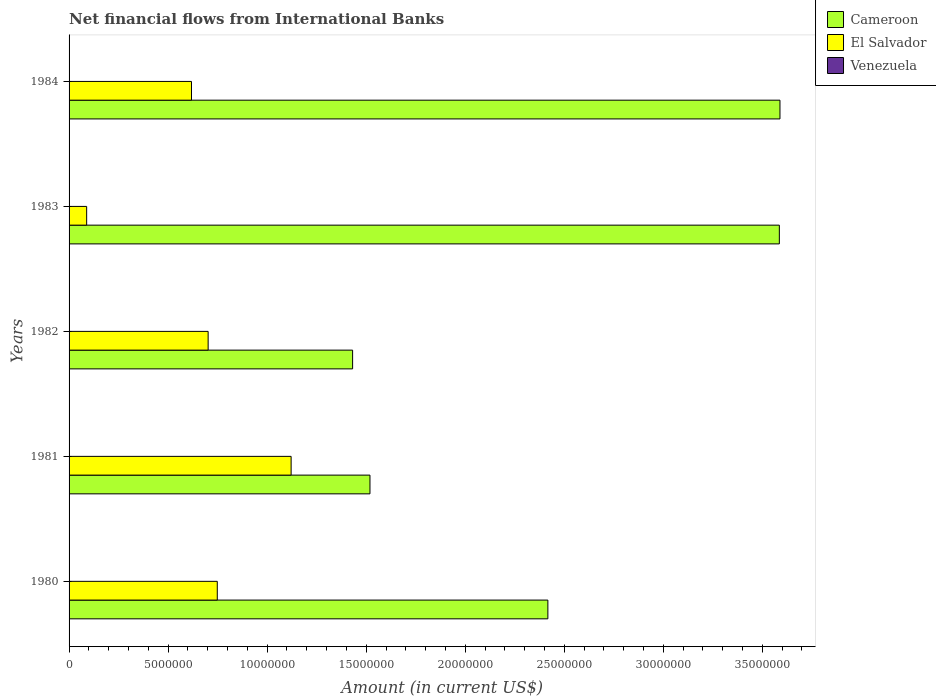How many different coloured bars are there?
Ensure brevity in your answer.  2. How many bars are there on the 3rd tick from the bottom?
Your answer should be very brief. 2. In how many cases, is the number of bars for a given year not equal to the number of legend labels?
Your answer should be very brief. 5. What is the net financial aid flows in Cameroon in 1983?
Your answer should be very brief. 3.59e+07. Across all years, what is the maximum net financial aid flows in Cameroon?
Offer a very short reply. 3.59e+07. Across all years, what is the minimum net financial aid flows in El Salvador?
Provide a short and direct response. 8.88e+05. What is the total net financial aid flows in Cameroon in the graph?
Your answer should be compact. 1.25e+08. What is the difference between the net financial aid flows in Cameroon in 1980 and that in 1981?
Provide a succinct answer. 8.98e+06. What is the difference between the net financial aid flows in El Salvador in 1981 and the net financial aid flows in Cameroon in 1980?
Offer a terse response. -1.30e+07. What is the average net financial aid flows in El Salvador per year?
Offer a terse response. 6.56e+06. In the year 1984, what is the difference between the net financial aid flows in El Salvador and net financial aid flows in Cameroon?
Keep it short and to the point. -2.97e+07. In how many years, is the net financial aid flows in Cameroon greater than 9000000 US$?
Give a very brief answer. 5. Is the net financial aid flows in El Salvador in 1980 less than that in 1982?
Your answer should be very brief. No. What is the difference between the highest and the second highest net financial aid flows in Cameroon?
Offer a very short reply. 3.10e+04. What is the difference between the highest and the lowest net financial aid flows in El Salvador?
Your answer should be very brief. 1.03e+07. In how many years, is the net financial aid flows in Venezuela greater than the average net financial aid flows in Venezuela taken over all years?
Give a very brief answer. 0. Is it the case that in every year, the sum of the net financial aid flows in El Salvador and net financial aid flows in Cameroon is greater than the net financial aid flows in Venezuela?
Provide a short and direct response. Yes. How many bars are there?
Provide a short and direct response. 10. Are the values on the major ticks of X-axis written in scientific E-notation?
Make the answer very short. No. Does the graph contain any zero values?
Your response must be concise. Yes. How many legend labels are there?
Offer a terse response. 3. What is the title of the graph?
Keep it short and to the point. Net financial flows from International Banks. Does "Thailand" appear as one of the legend labels in the graph?
Your response must be concise. No. What is the label or title of the Y-axis?
Provide a succinct answer. Years. What is the Amount (in current US$) of Cameroon in 1980?
Provide a succinct answer. 2.42e+07. What is the Amount (in current US$) in El Salvador in 1980?
Make the answer very short. 7.48e+06. What is the Amount (in current US$) of Cameroon in 1981?
Offer a terse response. 1.52e+07. What is the Amount (in current US$) in El Salvador in 1981?
Ensure brevity in your answer.  1.12e+07. What is the Amount (in current US$) of Venezuela in 1981?
Keep it short and to the point. 0. What is the Amount (in current US$) of Cameroon in 1982?
Your response must be concise. 1.43e+07. What is the Amount (in current US$) of El Salvador in 1982?
Make the answer very short. 7.02e+06. What is the Amount (in current US$) of Venezuela in 1982?
Offer a very short reply. 0. What is the Amount (in current US$) in Cameroon in 1983?
Your answer should be compact. 3.59e+07. What is the Amount (in current US$) in El Salvador in 1983?
Keep it short and to the point. 8.88e+05. What is the Amount (in current US$) of Cameroon in 1984?
Provide a succinct answer. 3.59e+07. What is the Amount (in current US$) in El Salvador in 1984?
Give a very brief answer. 6.18e+06. Across all years, what is the maximum Amount (in current US$) of Cameroon?
Provide a short and direct response. 3.59e+07. Across all years, what is the maximum Amount (in current US$) in El Salvador?
Ensure brevity in your answer.  1.12e+07. Across all years, what is the minimum Amount (in current US$) of Cameroon?
Ensure brevity in your answer.  1.43e+07. Across all years, what is the minimum Amount (in current US$) of El Salvador?
Offer a terse response. 8.88e+05. What is the total Amount (in current US$) of Cameroon in the graph?
Offer a terse response. 1.25e+08. What is the total Amount (in current US$) of El Salvador in the graph?
Ensure brevity in your answer.  3.28e+07. What is the difference between the Amount (in current US$) in Cameroon in 1980 and that in 1981?
Offer a very short reply. 8.98e+06. What is the difference between the Amount (in current US$) of El Salvador in 1980 and that in 1981?
Offer a very short reply. -3.73e+06. What is the difference between the Amount (in current US$) of Cameroon in 1980 and that in 1982?
Offer a very short reply. 9.86e+06. What is the difference between the Amount (in current US$) in El Salvador in 1980 and that in 1982?
Your answer should be compact. 4.61e+05. What is the difference between the Amount (in current US$) in Cameroon in 1980 and that in 1983?
Your answer should be very brief. -1.17e+07. What is the difference between the Amount (in current US$) in El Salvador in 1980 and that in 1983?
Provide a succinct answer. 6.59e+06. What is the difference between the Amount (in current US$) in Cameroon in 1980 and that in 1984?
Offer a terse response. -1.17e+07. What is the difference between the Amount (in current US$) of El Salvador in 1980 and that in 1984?
Your answer should be very brief. 1.30e+06. What is the difference between the Amount (in current US$) in Cameroon in 1981 and that in 1982?
Your answer should be compact. 8.77e+05. What is the difference between the Amount (in current US$) in El Salvador in 1981 and that in 1982?
Ensure brevity in your answer.  4.19e+06. What is the difference between the Amount (in current US$) in Cameroon in 1981 and that in 1983?
Ensure brevity in your answer.  -2.07e+07. What is the difference between the Amount (in current US$) of El Salvador in 1981 and that in 1983?
Ensure brevity in your answer.  1.03e+07. What is the difference between the Amount (in current US$) of Cameroon in 1981 and that in 1984?
Provide a short and direct response. -2.07e+07. What is the difference between the Amount (in current US$) in El Salvador in 1981 and that in 1984?
Your response must be concise. 5.03e+06. What is the difference between the Amount (in current US$) in Cameroon in 1982 and that in 1983?
Offer a very short reply. -2.15e+07. What is the difference between the Amount (in current US$) of El Salvador in 1982 and that in 1983?
Offer a very short reply. 6.13e+06. What is the difference between the Amount (in current US$) of Cameroon in 1982 and that in 1984?
Your response must be concise. -2.16e+07. What is the difference between the Amount (in current US$) of El Salvador in 1982 and that in 1984?
Ensure brevity in your answer.  8.41e+05. What is the difference between the Amount (in current US$) in Cameroon in 1983 and that in 1984?
Give a very brief answer. -3.10e+04. What is the difference between the Amount (in current US$) in El Salvador in 1983 and that in 1984?
Provide a succinct answer. -5.29e+06. What is the difference between the Amount (in current US$) of Cameroon in 1980 and the Amount (in current US$) of El Salvador in 1981?
Your answer should be very brief. 1.30e+07. What is the difference between the Amount (in current US$) in Cameroon in 1980 and the Amount (in current US$) in El Salvador in 1982?
Provide a short and direct response. 1.72e+07. What is the difference between the Amount (in current US$) in Cameroon in 1980 and the Amount (in current US$) in El Salvador in 1983?
Give a very brief answer. 2.33e+07. What is the difference between the Amount (in current US$) of Cameroon in 1980 and the Amount (in current US$) of El Salvador in 1984?
Your answer should be very brief. 1.80e+07. What is the difference between the Amount (in current US$) of Cameroon in 1981 and the Amount (in current US$) of El Salvador in 1982?
Offer a very short reply. 8.17e+06. What is the difference between the Amount (in current US$) of Cameroon in 1981 and the Amount (in current US$) of El Salvador in 1983?
Ensure brevity in your answer.  1.43e+07. What is the difference between the Amount (in current US$) in Cameroon in 1981 and the Amount (in current US$) in El Salvador in 1984?
Ensure brevity in your answer.  9.01e+06. What is the difference between the Amount (in current US$) of Cameroon in 1982 and the Amount (in current US$) of El Salvador in 1983?
Give a very brief answer. 1.34e+07. What is the difference between the Amount (in current US$) in Cameroon in 1982 and the Amount (in current US$) in El Salvador in 1984?
Give a very brief answer. 8.13e+06. What is the difference between the Amount (in current US$) in Cameroon in 1983 and the Amount (in current US$) in El Salvador in 1984?
Provide a succinct answer. 2.97e+07. What is the average Amount (in current US$) of Cameroon per year?
Keep it short and to the point. 2.51e+07. What is the average Amount (in current US$) in El Salvador per year?
Your answer should be compact. 6.56e+06. In the year 1980, what is the difference between the Amount (in current US$) in Cameroon and Amount (in current US$) in El Salvador?
Provide a short and direct response. 1.67e+07. In the year 1981, what is the difference between the Amount (in current US$) of Cameroon and Amount (in current US$) of El Salvador?
Keep it short and to the point. 3.98e+06. In the year 1982, what is the difference between the Amount (in current US$) of Cameroon and Amount (in current US$) of El Salvador?
Make the answer very short. 7.29e+06. In the year 1983, what is the difference between the Amount (in current US$) of Cameroon and Amount (in current US$) of El Salvador?
Offer a very short reply. 3.50e+07. In the year 1984, what is the difference between the Amount (in current US$) in Cameroon and Amount (in current US$) in El Salvador?
Ensure brevity in your answer.  2.97e+07. What is the ratio of the Amount (in current US$) of Cameroon in 1980 to that in 1981?
Your answer should be very brief. 1.59. What is the ratio of the Amount (in current US$) of El Salvador in 1980 to that in 1981?
Make the answer very short. 0.67. What is the ratio of the Amount (in current US$) of Cameroon in 1980 to that in 1982?
Offer a very short reply. 1.69. What is the ratio of the Amount (in current US$) in El Salvador in 1980 to that in 1982?
Make the answer very short. 1.07. What is the ratio of the Amount (in current US$) in Cameroon in 1980 to that in 1983?
Provide a short and direct response. 0.67. What is the ratio of the Amount (in current US$) in El Salvador in 1980 to that in 1983?
Give a very brief answer. 8.43. What is the ratio of the Amount (in current US$) in Cameroon in 1980 to that in 1984?
Your answer should be very brief. 0.67. What is the ratio of the Amount (in current US$) in El Salvador in 1980 to that in 1984?
Provide a succinct answer. 1.21. What is the ratio of the Amount (in current US$) in Cameroon in 1981 to that in 1982?
Offer a very short reply. 1.06. What is the ratio of the Amount (in current US$) of El Salvador in 1981 to that in 1982?
Provide a short and direct response. 1.6. What is the ratio of the Amount (in current US$) in Cameroon in 1981 to that in 1983?
Provide a succinct answer. 0.42. What is the ratio of the Amount (in current US$) of El Salvador in 1981 to that in 1983?
Provide a short and direct response. 12.62. What is the ratio of the Amount (in current US$) of Cameroon in 1981 to that in 1984?
Give a very brief answer. 0.42. What is the ratio of the Amount (in current US$) in El Salvador in 1981 to that in 1984?
Keep it short and to the point. 1.81. What is the ratio of the Amount (in current US$) in Cameroon in 1982 to that in 1983?
Keep it short and to the point. 0.4. What is the ratio of the Amount (in current US$) of El Salvador in 1982 to that in 1983?
Make the answer very short. 7.91. What is the ratio of the Amount (in current US$) of Cameroon in 1982 to that in 1984?
Offer a very short reply. 0.4. What is the ratio of the Amount (in current US$) in El Salvador in 1982 to that in 1984?
Your response must be concise. 1.14. What is the ratio of the Amount (in current US$) in El Salvador in 1983 to that in 1984?
Keep it short and to the point. 0.14. What is the difference between the highest and the second highest Amount (in current US$) of Cameroon?
Keep it short and to the point. 3.10e+04. What is the difference between the highest and the second highest Amount (in current US$) of El Salvador?
Give a very brief answer. 3.73e+06. What is the difference between the highest and the lowest Amount (in current US$) of Cameroon?
Offer a terse response. 2.16e+07. What is the difference between the highest and the lowest Amount (in current US$) of El Salvador?
Provide a succinct answer. 1.03e+07. 